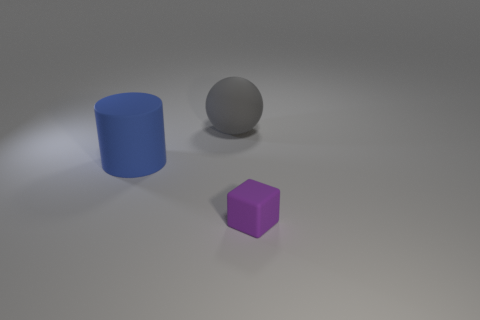There is a rubber object that is behind the big matte thing in front of the rubber sphere; what color is it?
Provide a short and direct response. Gray. Are there fewer blue cylinders that are behind the cylinder than gray things right of the tiny object?
Ensure brevity in your answer.  No. There is a purple rubber cube; does it have the same size as the object behind the big cylinder?
Your response must be concise. No. There is a thing that is both left of the small purple cube and in front of the big gray matte ball; what is its shape?
Provide a short and direct response. Cylinder. The cylinder that is the same material as the gray object is what size?
Your response must be concise. Large. What number of large matte things are on the right side of the large thing that is left of the gray matte object?
Provide a short and direct response. 1. Is the material of the big object left of the gray rubber sphere the same as the purple object?
Provide a short and direct response. Yes. Is there anything else that is the same material as the large ball?
Your response must be concise. Yes. How big is the rubber thing that is in front of the big matte thing that is in front of the gray rubber ball?
Offer a terse response. Small. There is a cylinder that is on the left side of the large thing behind the rubber thing that is to the left of the gray sphere; what size is it?
Offer a terse response. Large. 